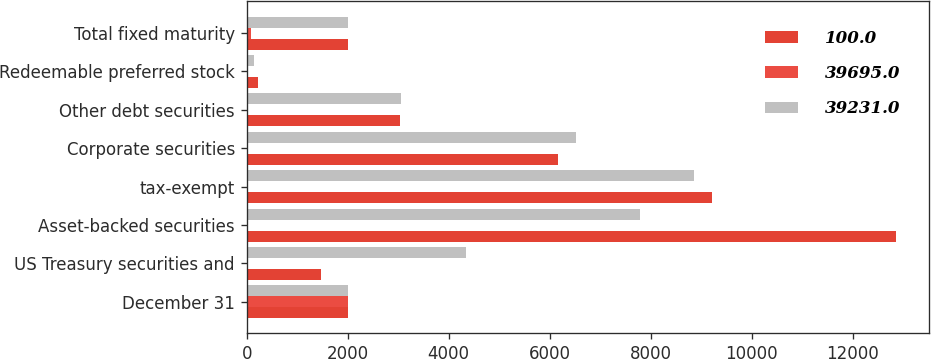<chart> <loc_0><loc_0><loc_500><loc_500><stacked_bar_chart><ecel><fcel>December 31<fcel>US Treasury securities and<fcel>Asset-backed securities<fcel>tax-exempt<fcel>Corporate securities<fcel>Other debt securities<fcel>Redeemable preferred stock<fcel>Total fixed maturity<nl><fcel>100<fcel>2005<fcel>1469<fcel>12859<fcel>9209<fcel>6165<fcel>3044<fcel>216<fcel>2004.5<nl><fcel>39695<fcel>2005<fcel>3.7<fcel>32.4<fcel>23.2<fcel>15.5<fcel>7.7<fcel>0.5<fcel>83<nl><fcel>39231<fcel>2004<fcel>4346<fcel>7788<fcel>8857<fcel>6513<fcel>3053<fcel>146<fcel>2004.5<nl></chart> 